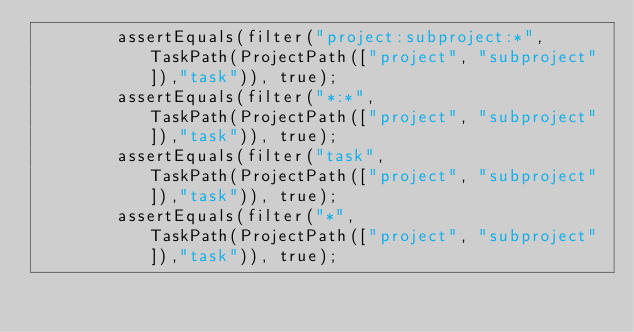Convert code to text. <code><loc_0><loc_0><loc_500><loc_500><_Ceylon_>		assertEquals(filter("project:subproject:*",    TaskPath(ProjectPath(["project", "subproject"]),"task")), true);
		assertEquals(filter("*:*",                     TaskPath(ProjectPath(["project", "subproject"]),"task")), true);
		assertEquals(filter("task",                    TaskPath(ProjectPath(["project", "subproject"]),"task")), true);
		assertEquals(filter("*",                       TaskPath(ProjectPath(["project", "subproject"]),"task")), true);
		</code> 